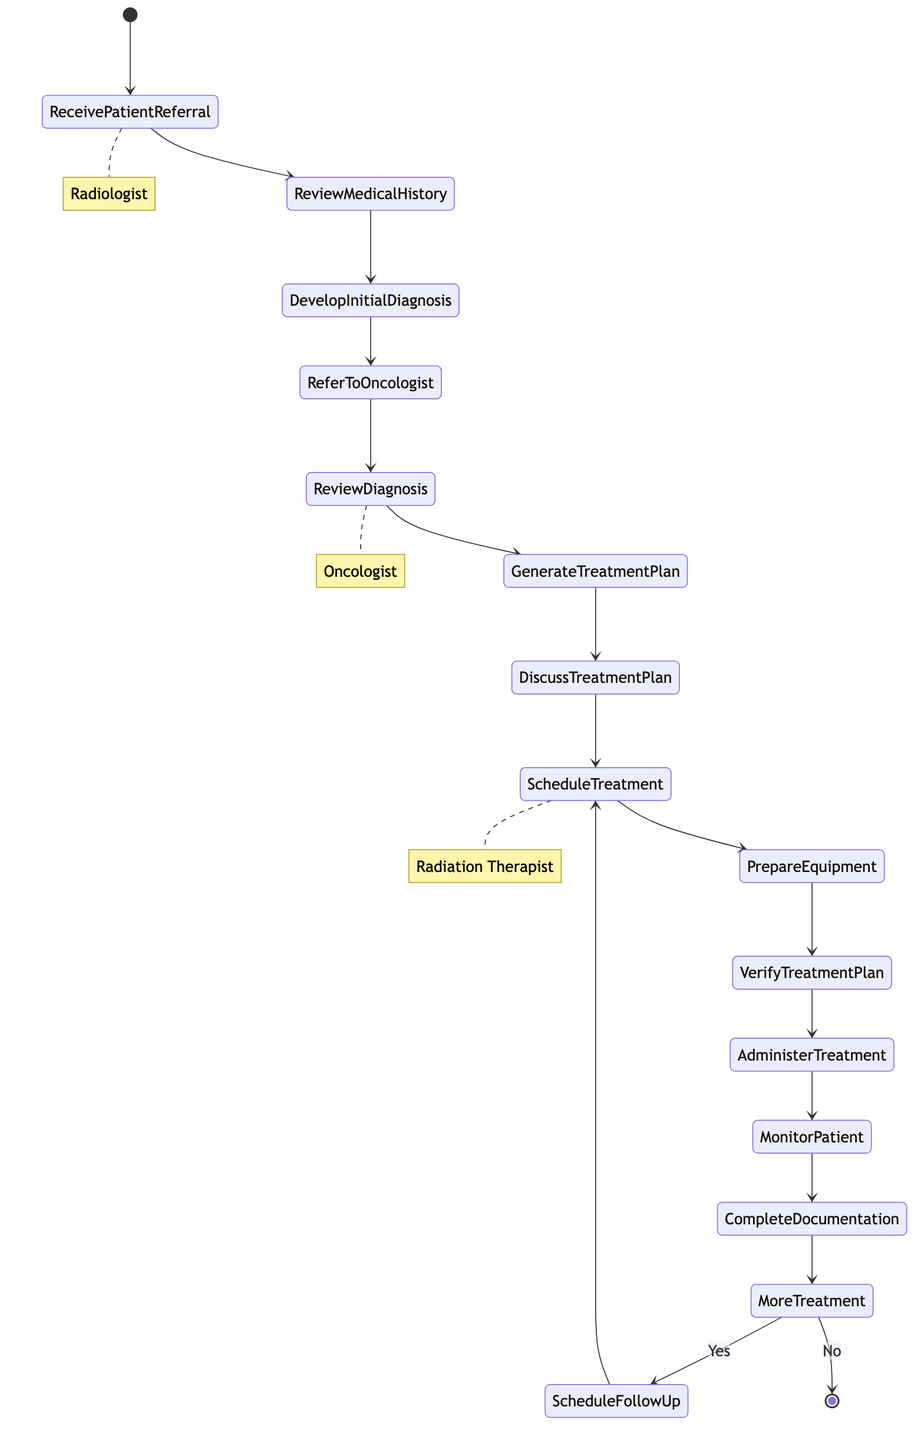What's the first activity in the workflow? The diagram indicates that the first activity is "Receive Patient Referral." This is the starting point of the entire process and signifies the initial interaction in the patient workflow.
Answer: Receive Patient Referral How many roles are involved in the diagram? The diagram contains three distinct roles: Radiologist, Oncologist, and Radiation Therapist. Each role has specific activities they are responsible for throughout the workflow.
Answer: Three What activity comes after the "Referring to the Oncologist"? Following "Refer to Oncologist for Treatment Planning," the next activity is "Review Patient's Diagnosis and Medical Records." This activity happens within the Oncologist's role, indicating the transition of information from the Radiologist to the Oncologist.
Answer: Review Patient's Diagnosis and Medical Records What decision is represented in the diagram? The diagram includes a decision point labeled "More Treatment Required?" This decision point is crucial as it determines whether the workflow will proceed to schedule follow-up appointments based on the patient's treatment needs.
Answer: More Treatment Required What activity directly follows the "Monitor Patient for Adverse Reactions"? After "Monitor Patient for Adverse Reactions," the subsequent activity is "Complete Treatment Session Documentation." This shows the closure of the treatment session and the need for proper documentation of the patient's experience during treatment.
Answer: Complete Treatment Session Documentation How does the workflow proceed if "More Treatment Required?" is answered with "yes"? If the answer to "More Treatment Required?" is "yes," the workflow directs to "Schedule Follow-Up Appointments." This flow indicates a continuation of care, necessitating further scheduling of treatment sessions.
Answer: Schedule Follow-Up Appointments Which role is responsible for adminstering the treatment? The role responsible for administering the treatment is the Radiation Therapist. This is specified in the workflow as a significant responsibility following the preparation and verification stages.
Answer: Radiation Therapist What is the last activity in the patient workflow? The final activity in the workflow is represented by the end node after the decision "More Treatment Required?" indicates "no." This concludes the patient treatment process.
Answer: End How many activities are initiated by the Oncologist? The Oncologist is involved in three activities: "Review Patient's Diagnosis and Medical Records," "Generate Treatment Plan," and "Discuss Treatment Plan with Radiation Therapist." This set of activities highlights the key role of the Oncologist in treatment planning.
Answer: Three 